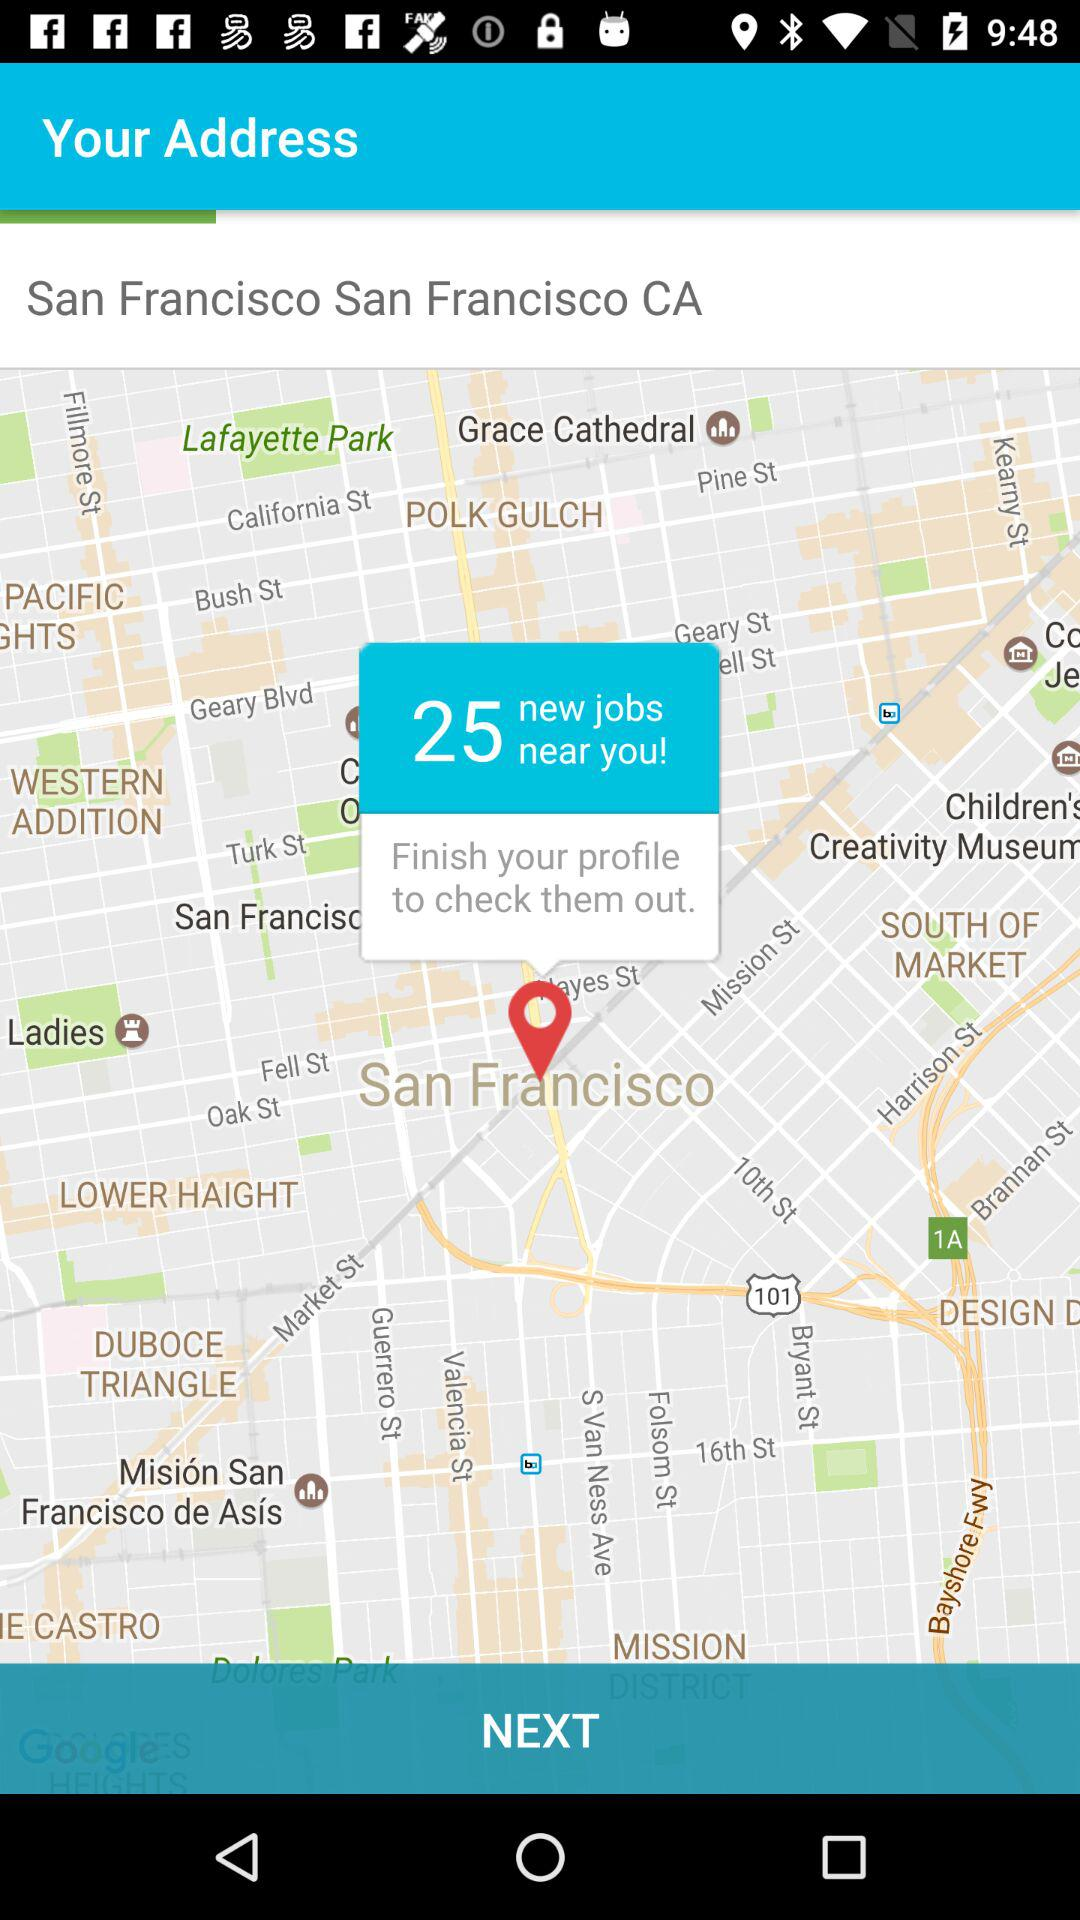Where is the nearest job located?
When the provided information is insufficient, respond with <no answer>. <no answer> 